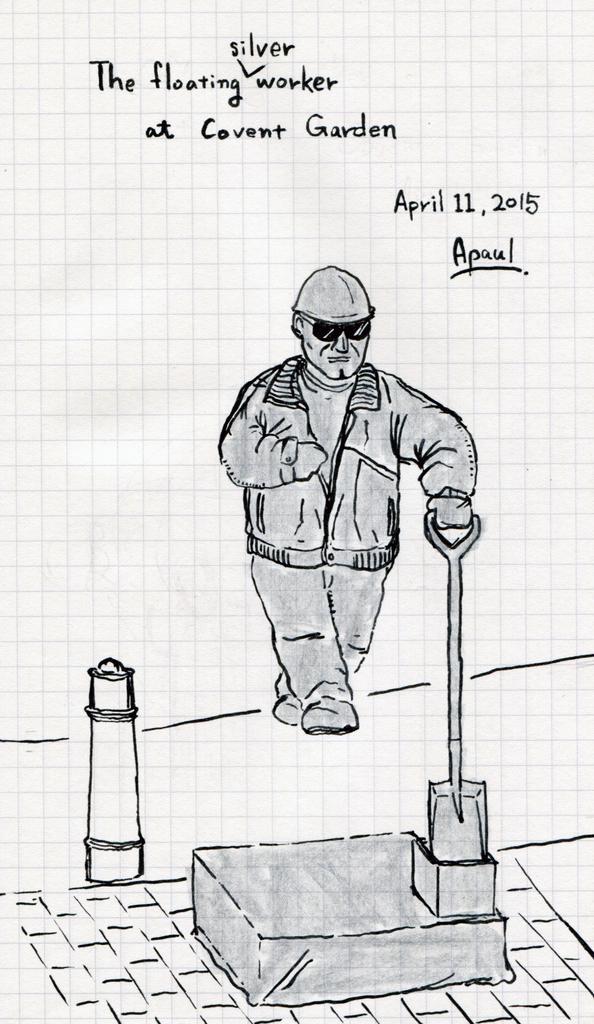In one or two sentences, can you explain what this image depicts? In the picture we can see sketch of a person who is holding some object in his hands and standing and top of the picture there are some words written. 